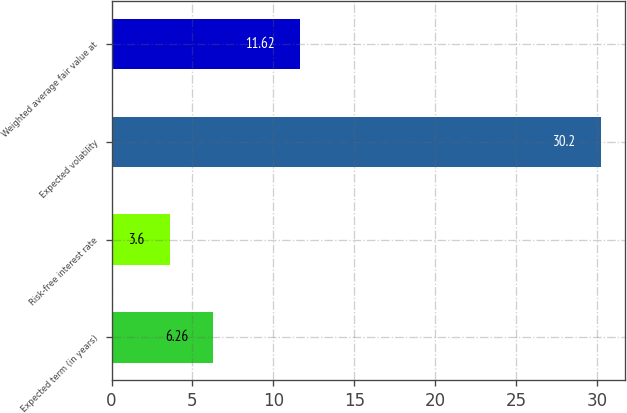Convert chart to OTSL. <chart><loc_0><loc_0><loc_500><loc_500><bar_chart><fcel>Expected term (in years)<fcel>Risk-free interest rate<fcel>Expected volatility<fcel>Weighted average fair value at<nl><fcel>6.26<fcel>3.6<fcel>30.2<fcel>11.62<nl></chart> 